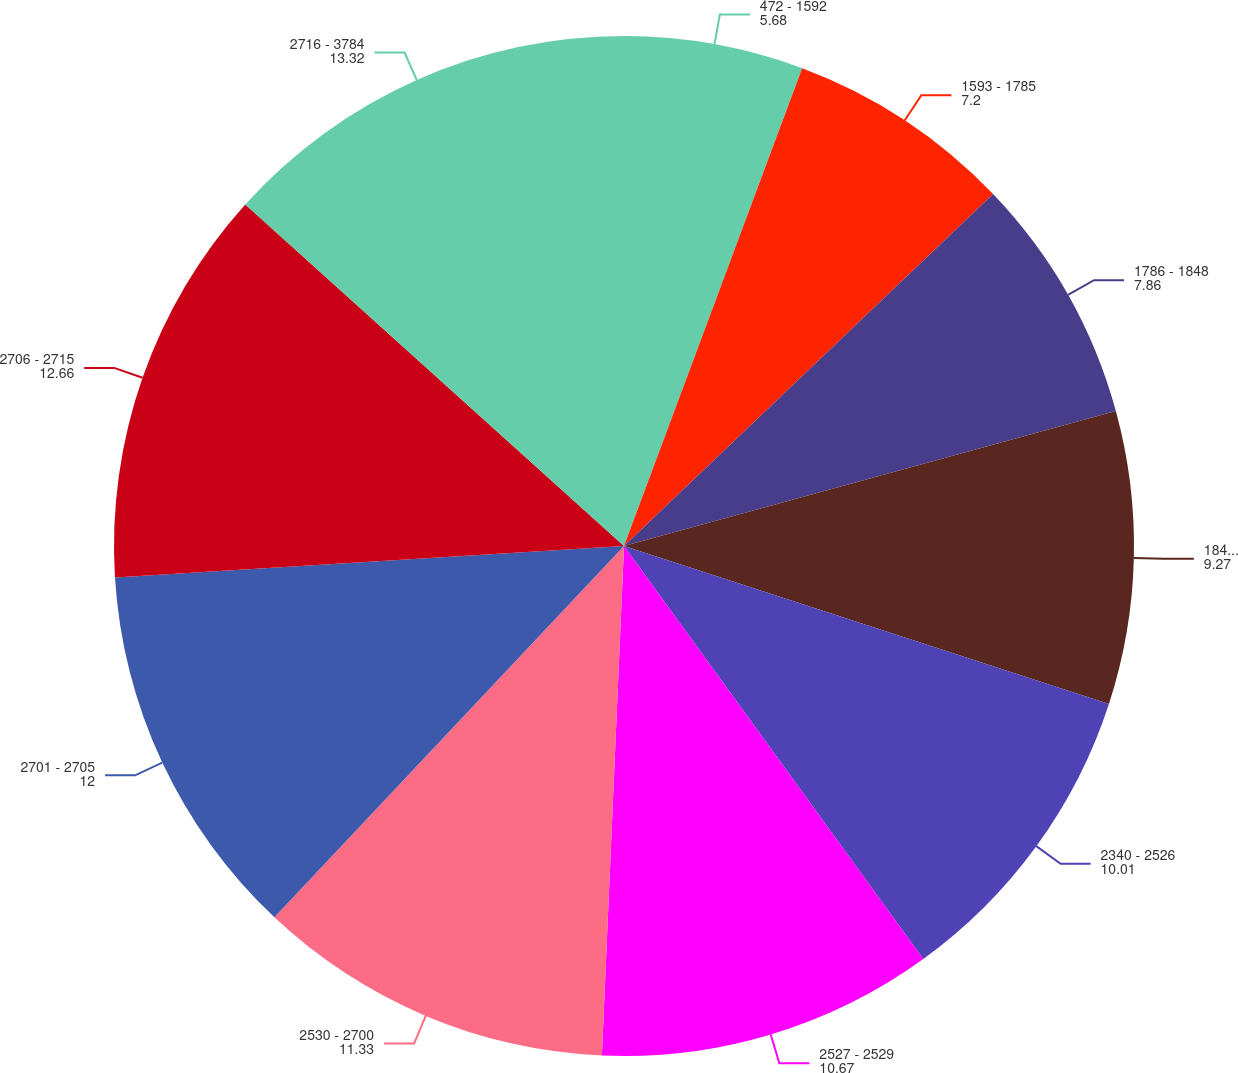Convert chart. <chart><loc_0><loc_0><loc_500><loc_500><pie_chart><fcel>472 - 1592<fcel>1593 - 1785<fcel>1786 - 1848<fcel>1849 - 2339<fcel>2340 - 2526<fcel>2527 - 2529<fcel>2530 - 2700<fcel>2701 - 2705<fcel>2706 - 2715<fcel>2716 - 3784<nl><fcel>5.68%<fcel>7.2%<fcel>7.86%<fcel>9.27%<fcel>10.01%<fcel>10.67%<fcel>11.33%<fcel>12.0%<fcel>12.66%<fcel>13.32%<nl></chart> 